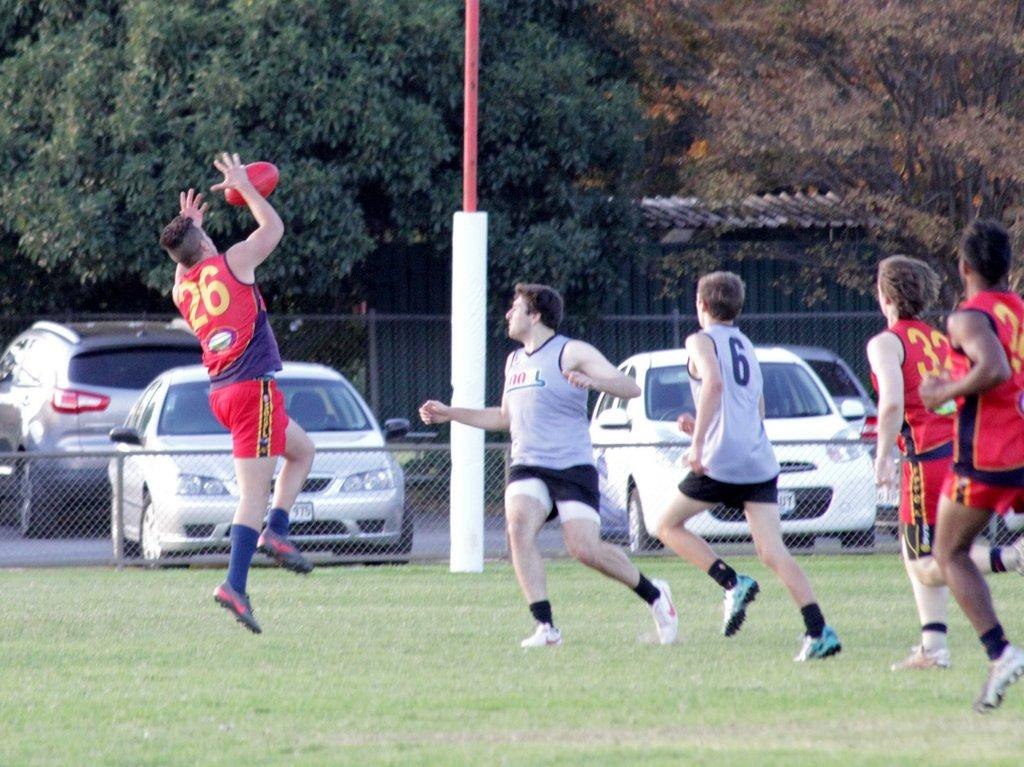What is happening with the group of people in the image? The group of people is on the ground. What is in the air in the image? There is a ball in the air. What can be seen in the background of the image? There is railing, vehicles on the road, a shed, and many trees in the background. Where is the store located in the image? There is no store present in the image. What type of cattle can be seen grazing near the shed in the image? There are no cattle present in the image; only the group of people, the ball, and various background elements are visible. 